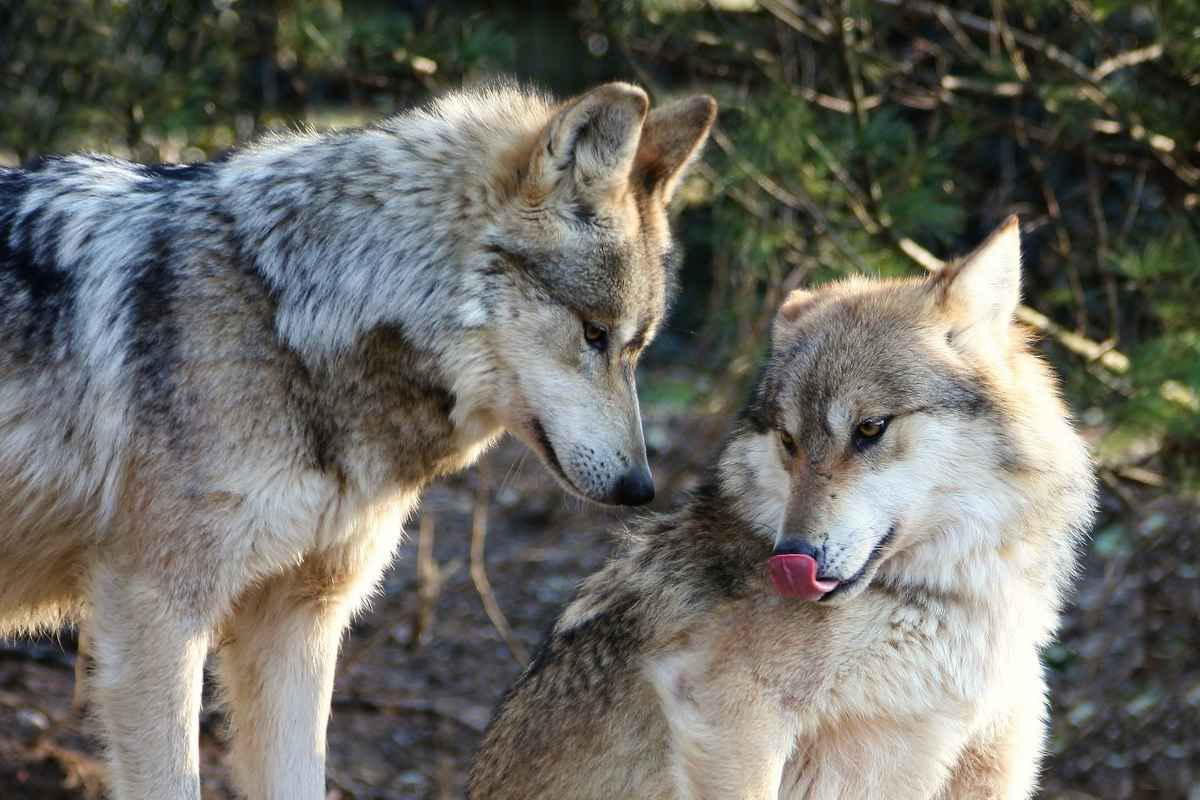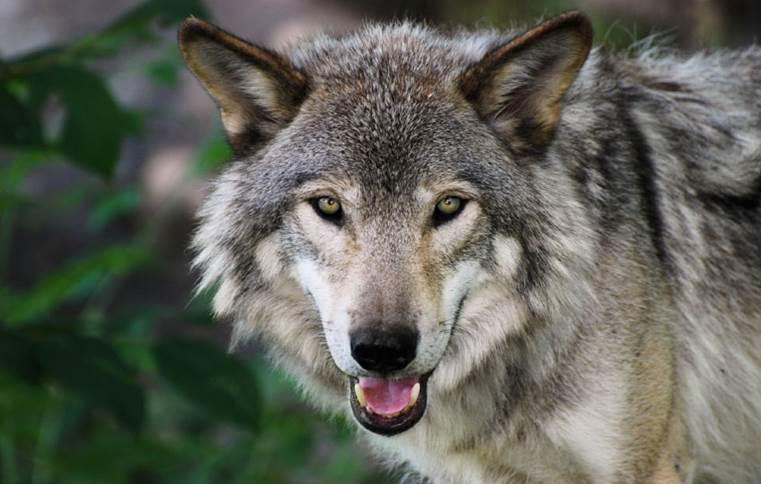The first image is the image on the left, the second image is the image on the right. For the images shown, is this caption "There are at least three wolves." true? Answer yes or no. Yes. The first image is the image on the left, the second image is the image on the right. Considering the images on both sides, is "The image on the left contains one more wolf than the image on the right." valid? Answer yes or no. Yes. 